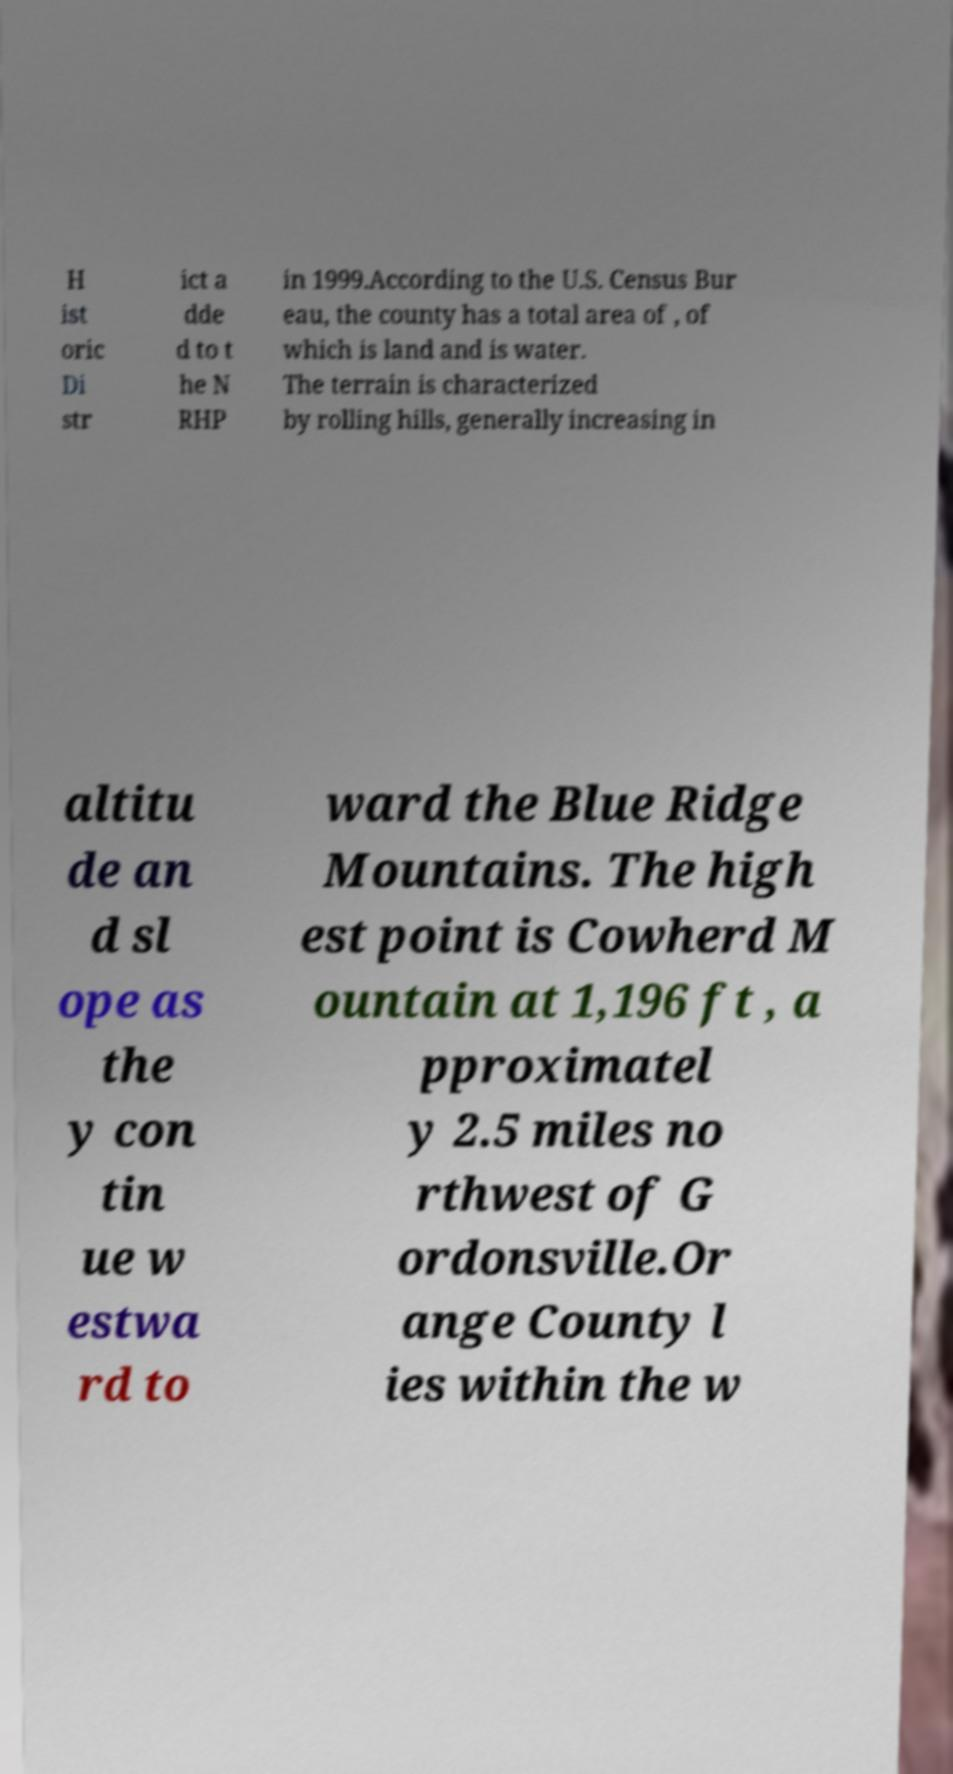Can you accurately transcribe the text from the provided image for me? H ist oric Di str ict a dde d to t he N RHP in 1999.According to the U.S. Census Bur eau, the county has a total area of , of which is land and is water. The terrain is characterized by rolling hills, generally increasing in altitu de an d sl ope as the y con tin ue w estwa rd to ward the Blue Ridge Mountains. The high est point is Cowherd M ountain at 1,196 ft , a pproximatel y 2.5 miles no rthwest of G ordonsville.Or ange County l ies within the w 